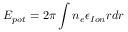Convert formula to latex. <formula><loc_0><loc_0><loc_500><loc_500>E _ { p o t } = 2 \pi \int n _ { e } \epsilon _ { I o n } r d r</formula> 